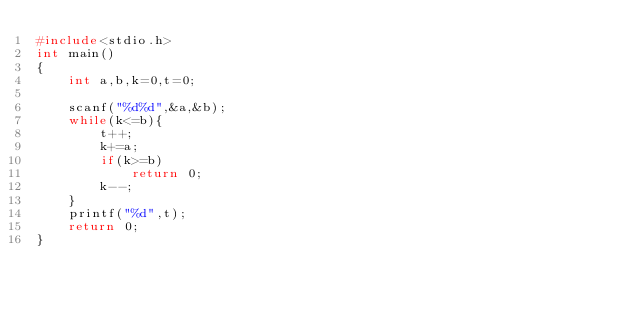<code> <loc_0><loc_0><loc_500><loc_500><_C_>#include<stdio.h>
int main()
{
	int a,b,k=0,t=0;

	scanf("%d%d",&a,&b);
	while(k<=b){
		t++;
		k+=a;
		if(k>=b)
			return 0;
		k--;
	}
	printf("%d",t);
	return 0;
}</code> 